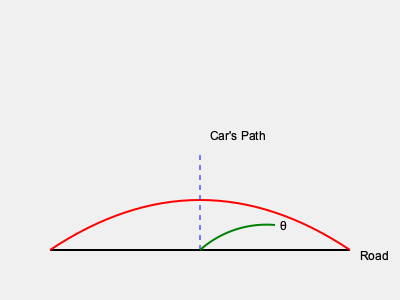During a legendary Group B rally event, a car enters a sharp turn with a dramatic drift. Based on the side-view diagram showing the car's path and the road, estimate the maximum angle of drift (θ) achieved by the car during this maneuver. To estimate the maximum angle of drift (θ), we need to analyze the diagram and follow these steps:

1. Observe that the car's path is represented by the red curved line, while the road is shown as the black straight line.

2. The maximum angle of drift occurs at the point where the car's path is furthest from the road, which is at the apex of the curve.

3. At this point, we can see a blue dashed line drawn vertically from the road to the car's path, representing the maximum deviation.

4. The angle θ is formed between this vertical line and a tangent to the car's path at the apex.

5. In Group B rally cars, extreme drift angles were common due to their high power and advanced all-wheel-drive systems.

6. Considering the era and the dramatic nature of Group B rallying, we can estimate that this angle is likely between 30° and 45°.

7. Looking at the green arc representing θ in the diagram, and comparing it to known reference angles, we can visually estimate that θ is approximately 40°.

This estimation takes into account the extreme nature of Group B rally driving, where cars often exhibited dramatic drift angles to navigate tight corners at high speeds.
Answer: Approximately 40° 